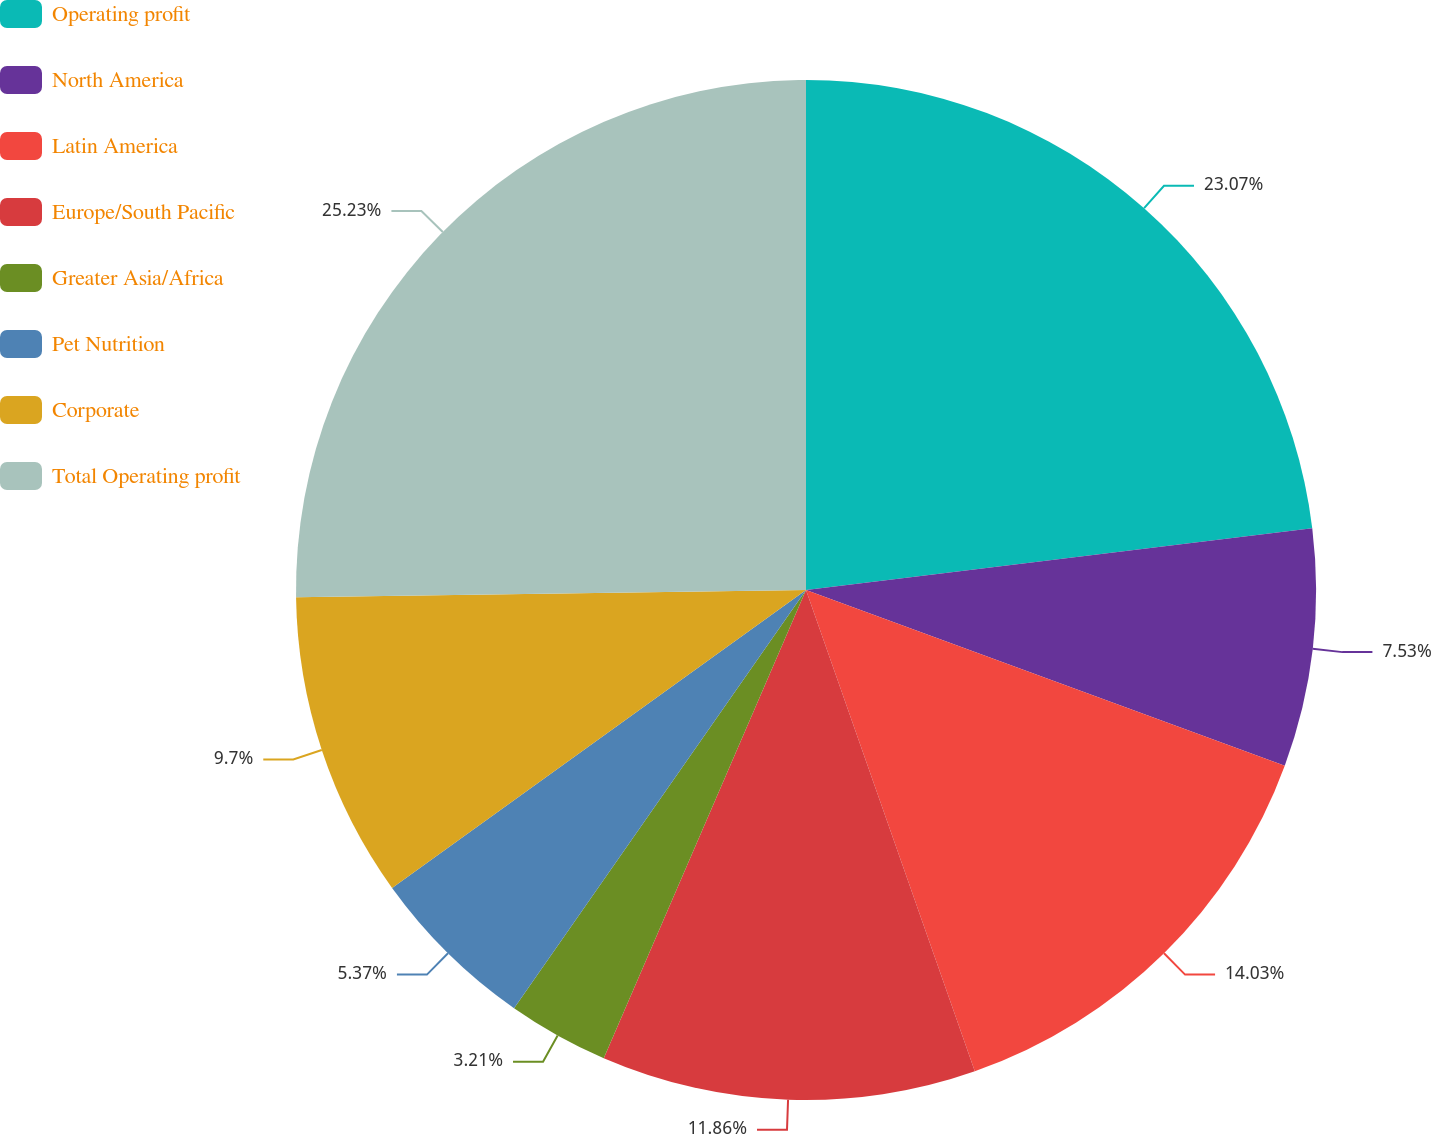<chart> <loc_0><loc_0><loc_500><loc_500><pie_chart><fcel>Operating profit<fcel>North America<fcel>Latin America<fcel>Europe/South Pacific<fcel>Greater Asia/Africa<fcel>Pet Nutrition<fcel>Corporate<fcel>Total Operating profit<nl><fcel>23.07%<fcel>7.53%<fcel>14.03%<fcel>11.86%<fcel>3.21%<fcel>5.37%<fcel>9.7%<fcel>25.23%<nl></chart> 